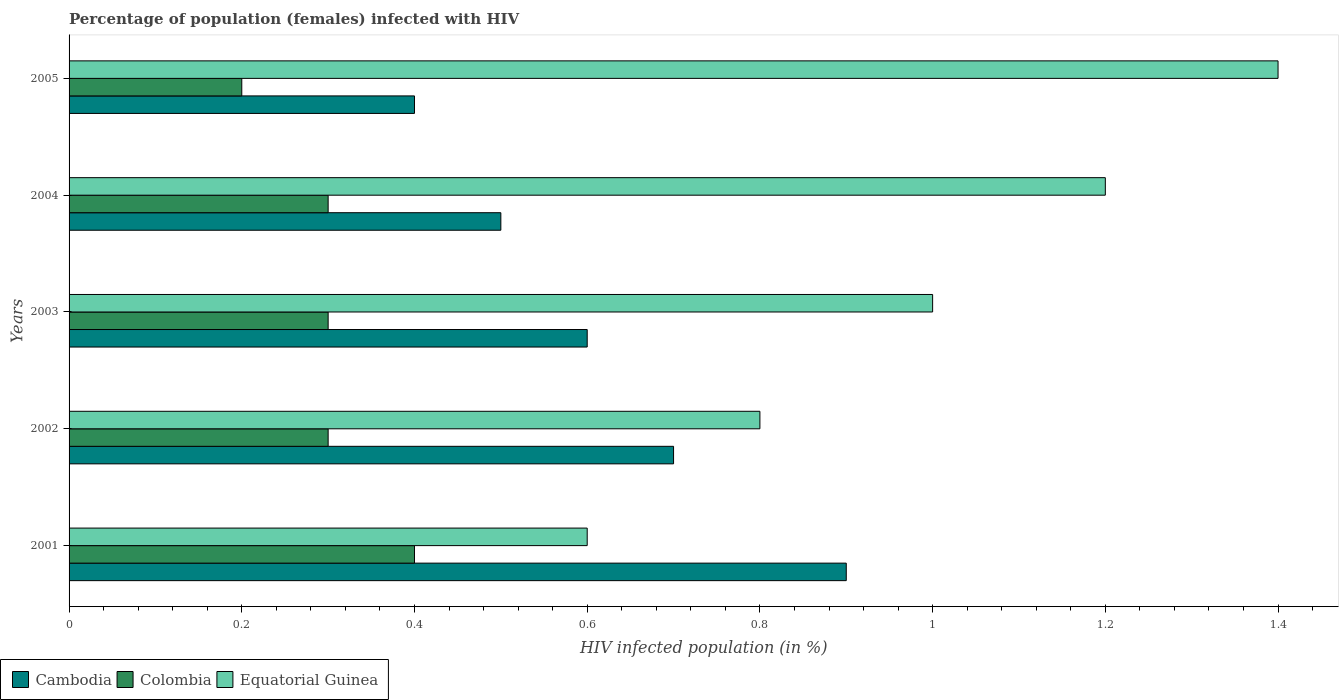How many different coloured bars are there?
Give a very brief answer. 3. Are the number of bars on each tick of the Y-axis equal?
Make the answer very short. Yes. How many bars are there on the 4th tick from the bottom?
Keep it short and to the point. 3. In how many cases, is the number of bars for a given year not equal to the number of legend labels?
Provide a succinct answer. 0. Across all years, what is the minimum percentage of HIV infected female population in Cambodia?
Your response must be concise. 0.4. In which year was the percentage of HIV infected female population in Colombia maximum?
Your response must be concise. 2001. What is the difference between the percentage of HIV infected female population in Equatorial Guinea in 2003 and that in 2005?
Provide a short and direct response. -0.4. What is the difference between the percentage of HIV infected female population in Cambodia in 2005 and the percentage of HIV infected female population in Colombia in 2003?
Keep it short and to the point. 0.1. What is the average percentage of HIV infected female population in Cambodia per year?
Keep it short and to the point. 0.62. In the year 2001, what is the difference between the percentage of HIV infected female population in Equatorial Guinea and percentage of HIV infected female population in Cambodia?
Give a very brief answer. -0.3. What is the ratio of the percentage of HIV infected female population in Cambodia in 2001 to that in 2005?
Offer a terse response. 2.25. Is the difference between the percentage of HIV infected female population in Equatorial Guinea in 2004 and 2005 greater than the difference between the percentage of HIV infected female population in Cambodia in 2004 and 2005?
Keep it short and to the point. No. What is the difference between the highest and the second highest percentage of HIV infected female population in Colombia?
Make the answer very short. 0.1. What is the difference between the highest and the lowest percentage of HIV infected female population in Colombia?
Offer a terse response. 0.2. What does the 1st bar from the top in 2001 represents?
Provide a succinct answer. Equatorial Guinea. What does the 2nd bar from the bottom in 2005 represents?
Ensure brevity in your answer.  Colombia. Is it the case that in every year, the sum of the percentage of HIV infected female population in Equatorial Guinea and percentage of HIV infected female population in Cambodia is greater than the percentage of HIV infected female population in Colombia?
Provide a succinct answer. Yes. How many bars are there?
Your answer should be compact. 15. Are all the bars in the graph horizontal?
Ensure brevity in your answer.  Yes. Does the graph contain any zero values?
Provide a succinct answer. No. Does the graph contain grids?
Your answer should be very brief. No. How are the legend labels stacked?
Provide a short and direct response. Horizontal. What is the title of the graph?
Your answer should be very brief. Percentage of population (females) infected with HIV. Does "East Asia (developing only)" appear as one of the legend labels in the graph?
Your answer should be compact. No. What is the label or title of the X-axis?
Provide a succinct answer. HIV infected population (in %). What is the label or title of the Y-axis?
Make the answer very short. Years. What is the HIV infected population (in %) in Cambodia in 2001?
Give a very brief answer. 0.9. What is the HIV infected population (in %) of Equatorial Guinea in 2001?
Your answer should be very brief. 0.6. What is the HIV infected population (in %) in Cambodia in 2002?
Provide a succinct answer. 0.7. What is the HIV infected population (in %) in Colombia in 2002?
Give a very brief answer. 0.3. What is the HIV infected population (in %) in Colombia in 2003?
Offer a terse response. 0.3. What is the HIV infected population (in %) of Equatorial Guinea in 2003?
Your answer should be compact. 1. What is the HIV infected population (in %) of Colombia in 2005?
Offer a terse response. 0.2. Across all years, what is the minimum HIV infected population (in %) in Equatorial Guinea?
Provide a short and direct response. 0.6. What is the total HIV infected population (in %) in Equatorial Guinea in the graph?
Give a very brief answer. 5. What is the difference between the HIV infected population (in %) of Cambodia in 2001 and that in 2002?
Provide a succinct answer. 0.2. What is the difference between the HIV infected population (in %) in Colombia in 2001 and that in 2002?
Give a very brief answer. 0.1. What is the difference between the HIV infected population (in %) of Cambodia in 2001 and that in 2003?
Offer a terse response. 0.3. What is the difference between the HIV infected population (in %) of Colombia in 2001 and that in 2003?
Ensure brevity in your answer.  0.1. What is the difference between the HIV infected population (in %) in Equatorial Guinea in 2001 and that in 2003?
Offer a terse response. -0.4. What is the difference between the HIV infected population (in %) of Colombia in 2001 and that in 2004?
Offer a very short reply. 0.1. What is the difference between the HIV infected population (in %) of Equatorial Guinea in 2001 and that in 2004?
Your answer should be compact. -0.6. What is the difference between the HIV infected population (in %) in Cambodia in 2001 and that in 2005?
Make the answer very short. 0.5. What is the difference between the HIV infected population (in %) of Colombia in 2001 and that in 2005?
Offer a very short reply. 0.2. What is the difference between the HIV infected population (in %) of Colombia in 2002 and that in 2003?
Your answer should be compact. 0. What is the difference between the HIV infected population (in %) in Equatorial Guinea in 2002 and that in 2003?
Give a very brief answer. -0.2. What is the difference between the HIV infected population (in %) of Equatorial Guinea in 2002 and that in 2004?
Offer a terse response. -0.4. What is the difference between the HIV infected population (in %) of Equatorial Guinea in 2003 and that in 2004?
Your response must be concise. -0.2. What is the difference between the HIV infected population (in %) of Equatorial Guinea in 2003 and that in 2005?
Provide a succinct answer. -0.4. What is the difference between the HIV infected population (in %) of Colombia in 2004 and that in 2005?
Give a very brief answer. 0.1. What is the difference between the HIV infected population (in %) in Cambodia in 2001 and the HIV infected population (in %) in Colombia in 2002?
Offer a very short reply. 0.6. What is the difference between the HIV infected population (in %) in Cambodia in 2001 and the HIV infected population (in %) in Equatorial Guinea in 2004?
Your response must be concise. -0.3. What is the difference between the HIV infected population (in %) of Cambodia in 2001 and the HIV infected population (in %) of Equatorial Guinea in 2005?
Ensure brevity in your answer.  -0.5. What is the difference between the HIV infected population (in %) in Cambodia in 2002 and the HIV infected population (in %) in Colombia in 2003?
Make the answer very short. 0.4. What is the difference between the HIV infected population (in %) in Colombia in 2002 and the HIV infected population (in %) in Equatorial Guinea in 2003?
Give a very brief answer. -0.7. What is the difference between the HIV infected population (in %) in Cambodia in 2002 and the HIV infected population (in %) in Colombia in 2004?
Ensure brevity in your answer.  0.4. What is the difference between the HIV infected population (in %) of Colombia in 2002 and the HIV infected population (in %) of Equatorial Guinea in 2004?
Your answer should be very brief. -0.9. What is the difference between the HIV infected population (in %) in Cambodia in 2002 and the HIV infected population (in %) in Equatorial Guinea in 2005?
Ensure brevity in your answer.  -0.7. What is the difference between the HIV infected population (in %) of Colombia in 2002 and the HIV infected population (in %) of Equatorial Guinea in 2005?
Offer a very short reply. -1.1. What is the difference between the HIV infected population (in %) in Cambodia in 2003 and the HIV infected population (in %) in Colombia in 2005?
Your answer should be very brief. 0.4. What is the difference between the HIV infected population (in %) of Cambodia in 2003 and the HIV infected population (in %) of Equatorial Guinea in 2005?
Offer a very short reply. -0.8. What is the difference between the HIV infected population (in %) in Cambodia in 2004 and the HIV infected population (in %) in Colombia in 2005?
Your response must be concise. 0.3. What is the difference between the HIV infected population (in %) of Cambodia in 2004 and the HIV infected population (in %) of Equatorial Guinea in 2005?
Keep it short and to the point. -0.9. What is the difference between the HIV infected population (in %) in Colombia in 2004 and the HIV infected population (in %) in Equatorial Guinea in 2005?
Provide a short and direct response. -1.1. What is the average HIV infected population (in %) of Cambodia per year?
Give a very brief answer. 0.62. What is the average HIV infected population (in %) in Colombia per year?
Offer a terse response. 0.3. What is the average HIV infected population (in %) in Equatorial Guinea per year?
Provide a succinct answer. 1. In the year 2001, what is the difference between the HIV infected population (in %) in Colombia and HIV infected population (in %) in Equatorial Guinea?
Your answer should be very brief. -0.2. In the year 2002, what is the difference between the HIV infected population (in %) of Colombia and HIV infected population (in %) of Equatorial Guinea?
Ensure brevity in your answer.  -0.5. In the year 2003, what is the difference between the HIV infected population (in %) in Cambodia and HIV infected population (in %) in Colombia?
Provide a succinct answer. 0.3. In the year 2003, what is the difference between the HIV infected population (in %) of Cambodia and HIV infected population (in %) of Equatorial Guinea?
Provide a short and direct response. -0.4. In the year 2005, what is the difference between the HIV infected population (in %) of Cambodia and HIV infected population (in %) of Colombia?
Your answer should be very brief. 0.2. What is the ratio of the HIV infected population (in %) in Cambodia in 2001 to that in 2002?
Your answer should be very brief. 1.29. What is the ratio of the HIV infected population (in %) in Colombia in 2001 to that in 2002?
Your response must be concise. 1.33. What is the ratio of the HIV infected population (in %) in Equatorial Guinea in 2001 to that in 2002?
Offer a very short reply. 0.75. What is the ratio of the HIV infected population (in %) of Cambodia in 2001 to that in 2003?
Your answer should be very brief. 1.5. What is the ratio of the HIV infected population (in %) of Equatorial Guinea in 2001 to that in 2003?
Your response must be concise. 0.6. What is the ratio of the HIV infected population (in %) in Cambodia in 2001 to that in 2004?
Give a very brief answer. 1.8. What is the ratio of the HIV infected population (in %) of Colombia in 2001 to that in 2004?
Provide a succinct answer. 1.33. What is the ratio of the HIV infected population (in %) in Equatorial Guinea in 2001 to that in 2004?
Give a very brief answer. 0.5. What is the ratio of the HIV infected population (in %) in Cambodia in 2001 to that in 2005?
Offer a terse response. 2.25. What is the ratio of the HIV infected population (in %) in Colombia in 2001 to that in 2005?
Provide a short and direct response. 2. What is the ratio of the HIV infected population (in %) in Equatorial Guinea in 2001 to that in 2005?
Offer a terse response. 0.43. What is the ratio of the HIV infected population (in %) of Colombia in 2002 to that in 2003?
Your response must be concise. 1. What is the ratio of the HIV infected population (in %) in Colombia in 2002 to that in 2004?
Your response must be concise. 1. What is the ratio of the HIV infected population (in %) in Cambodia in 2002 to that in 2005?
Offer a terse response. 1.75. What is the ratio of the HIV infected population (in %) in Colombia in 2002 to that in 2005?
Give a very brief answer. 1.5. What is the ratio of the HIV infected population (in %) of Cambodia in 2003 to that in 2004?
Your answer should be compact. 1.2. What is the ratio of the HIV infected population (in %) in Colombia in 2003 to that in 2004?
Make the answer very short. 1. What is the ratio of the HIV infected population (in %) in Cambodia in 2003 to that in 2005?
Keep it short and to the point. 1.5. What is the ratio of the HIV infected population (in %) of Equatorial Guinea in 2003 to that in 2005?
Ensure brevity in your answer.  0.71. What is the ratio of the HIV infected population (in %) in Cambodia in 2004 to that in 2005?
Your answer should be very brief. 1.25. What is the ratio of the HIV infected population (in %) in Colombia in 2004 to that in 2005?
Your response must be concise. 1.5. What is the ratio of the HIV infected population (in %) of Equatorial Guinea in 2004 to that in 2005?
Your answer should be very brief. 0.86. What is the difference between the highest and the lowest HIV infected population (in %) in Cambodia?
Your response must be concise. 0.5. 